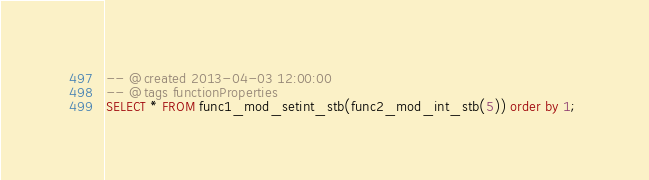Convert code to text. <code><loc_0><loc_0><loc_500><loc_500><_SQL_>-- @created 2013-04-03 12:00:00
-- @tags functionProperties 
SELECT * FROM func1_mod_setint_stb(func2_mod_int_stb(5)) order by 1; 
</code> 